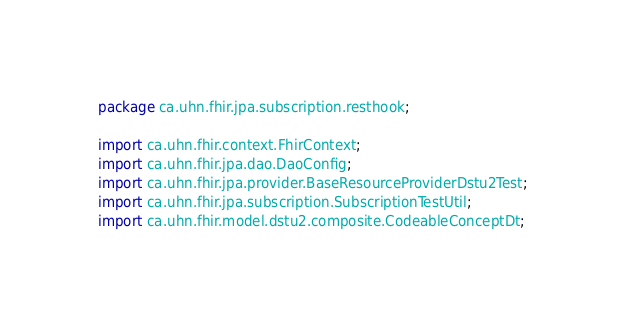<code> <loc_0><loc_0><loc_500><loc_500><_Java_>package ca.uhn.fhir.jpa.subscription.resthook;

import ca.uhn.fhir.context.FhirContext;
import ca.uhn.fhir.jpa.dao.DaoConfig;
import ca.uhn.fhir.jpa.provider.BaseResourceProviderDstu2Test;
import ca.uhn.fhir.jpa.subscription.SubscriptionTestUtil;
import ca.uhn.fhir.model.dstu2.composite.CodeableConceptDt;</code> 